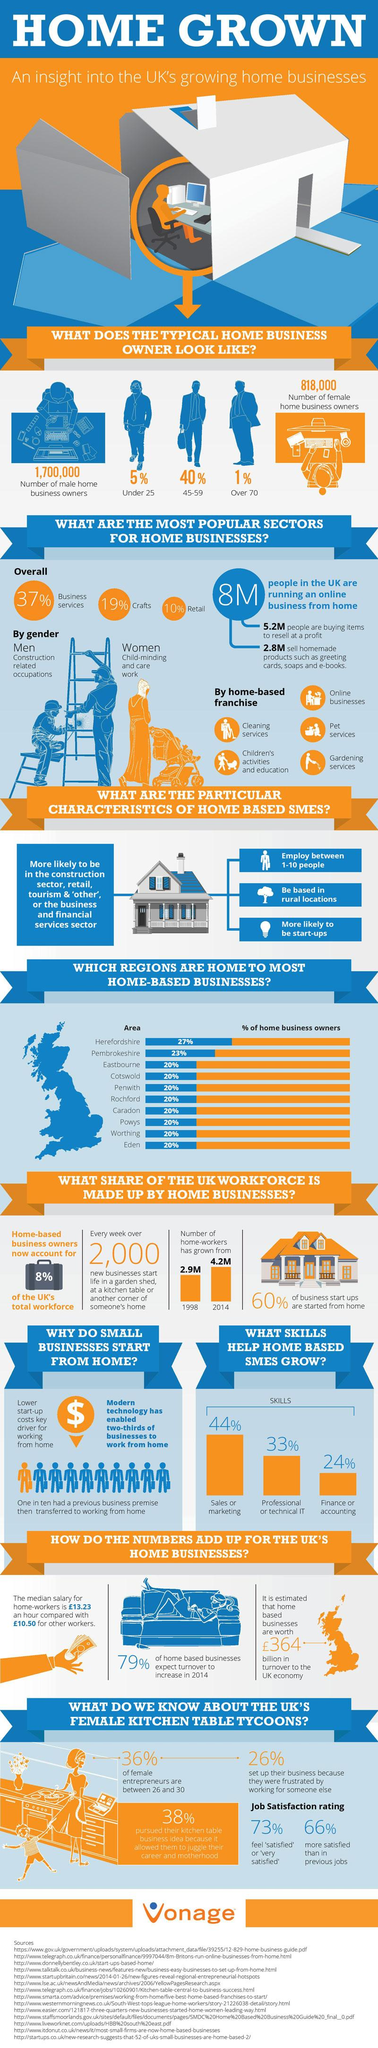Draw attention to some important aspects in this diagram. The number of home workers increased by 44.8% from 1998 to 2014. In Hertfordshire, Pembroke shire, and Eastbourne, 27%, 23%, and 20% of home business owners, respectively, were identified. The study found that 34% of female entrepreneurs who are less satisfied with their current job than in their previous job. The male category is more involved in home businesses than the female category. According to the given data, 64% of female entrepreneurs do not belong to the age group of 26-30 years old. 